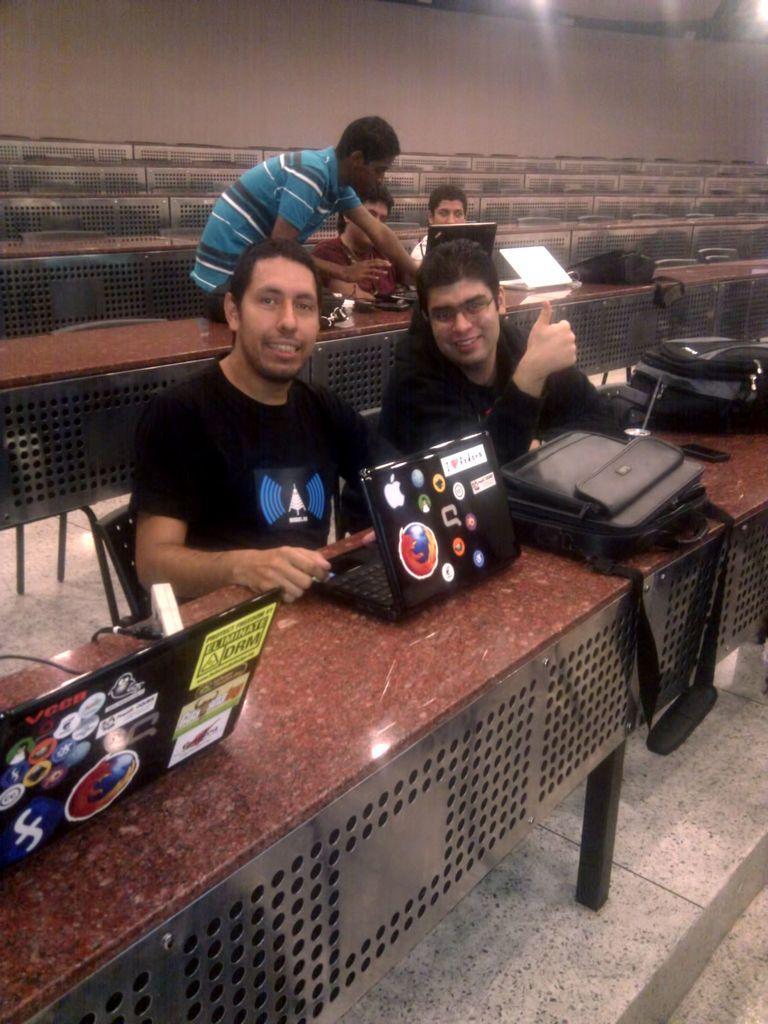How would you summarize this image in a sentence or two? In this image I can see few people are sitting and a person is standing. I can also see few laptops and bag on these tables. 